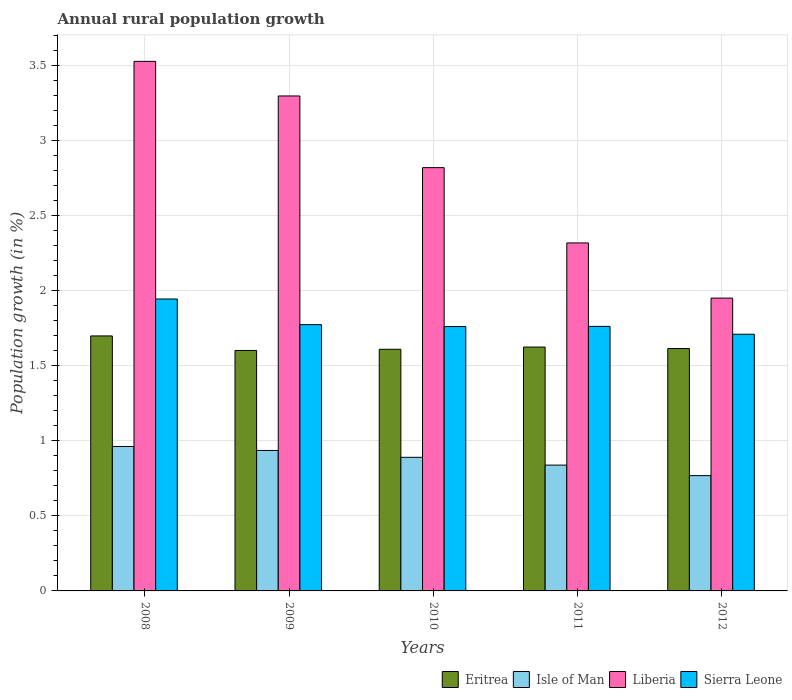How many different coloured bars are there?
Keep it short and to the point. 4. How many groups of bars are there?
Offer a very short reply. 5. What is the percentage of rural population growth in Isle of Man in 2009?
Give a very brief answer. 0.94. Across all years, what is the maximum percentage of rural population growth in Liberia?
Your answer should be compact. 3.53. Across all years, what is the minimum percentage of rural population growth in Eritrea?
Make the answer very short. 1.6. In which year was the percentage of rural population growth in Liberia minimum?
Offer a terse response. 2012. What is the total percentage of rural population growth in Liberia in the graph?
Keep it short and to the point. 13.93. What is the difference between the percentage of rural population growth in Sierra Leone in 2008 and that in 2012?
Ensure brevity in your answer.  0.24. What is the difference between the percentage of rural population growth in Sierra Leone in 2011 and the percentage of rural population growth in Eritrea in 2009?
Give a very brief answer. 0.16. What is the average percentage of rural population growth in Liberia per year?
Your response must be concise. 2.79. In the year 2012, what is the difference between the percentage of rural population growth in Liberia and percentage of rural population growth in Eritrea?
Your response must be concise. 0.34. In how many years, is the percentage of rural population growth in Liberia greater than 0.7 %?
Your response must be concise. 5. What is the ratio of the percentage of rural population growth in Liberia in 2010 to that in 2012?
Ensure brevity in your answer.  1.45. Is the percentage of rural population growth in Isle of Man in 2010 less than that in 2012?
Provide a short and direct response. No. Is the difference between the percentage of rural population growth in Liberia in 2009 and 2012 greater than the difference between the percentage of rural population growth in Eritrea in 2009 and 2012?
Make the answer very short. Yes. What is the difference between the highest and the second highest percentage of rural population growth in Sierra Leone?
Offer a terse response. 0.17. What is the difference between the highest and the lowest percentage of rural population growth in Liberia?
Provide a short and direct response. 1.58. What does the 3rd bar from the left in 2010 represents?
Offer a very short reply. Liberia. What does the 3rd bar from the right in 2012 represents?
Provide a short and direct response. Isle of Man. Is it the case that in every year, the sum of the percentage of rural population growth in Sierra Leone and percentage of rural population growth in Liberia is greater than the percentage of rural population growth in Isle of Man?
Offer a terse response. Yes. What is the difference between two consecutive major ticks on the Y-axis?
Your answer should be compact. 0.5. Are the values on the major ticks of Y-axis written in scientific E-notation?
Keep it short and to the point. No. Does the graph contain grids?
Your answer should be compact. Yes. Where does the legend appear in the graph?
Keep it short and to the point. Bottom right. How many legend labels are there?
Make the answer very short. 4. How are the legend labels stacked?
Provide a short and direct response. Horizontal. What is the title of the graph?
Ensure brevity in your answer.  Annual rural population growth. Does "Cayman Islands" appear as one of the legend labels in the graph?
Make the answer very short. No. What is the label or title of the X-axis?
Provide a succinct answer. Years. What is the label or title of the Y-axis?
Make the answer very short. Population growth (in %). What is the Population growth (in %) of Eritrea in 2008?
Ensure brevity in your answer.  1.7. What is the Population growth (in %) in Isle of Man in 2008?
Provide a succinct answer. 0.96. What is the Population growth (in %) in Liberia in 2008?
Offer a terse response. 3.53. What is the Population growth (in %) in Sierra Leone in 2008?
Ensure brevity in your answer.  1.95. What is the Population growth (in %) of Eritrea in 2009?
Keep it short and to the point. 1.6. What is the Population growth (in %) of Isle of Man in 2009?
Give a very brief answer. 0.94. What is the Population growth (in %) of Liberia in 2009?
Your answer should be very brief. 3.3. What is the Population growth (in %) of Sierra Leone in 2009?
Make the answer very short. 1.78. What is the Population growth (in %) of Eritrea in 2010?
Keep it short and to the point. 1.61. What is the Population growth (in %) of Isle of Man in 2010?
Give a very brief answer. 0.89. What is the Population growth (in %) of Liberia in 2010?
Your response must be concise. 2.82. What is the Population growth (in %) of Sierra Leone in 2010?
Make the answer very short. 1.76. What is the Population growth (in %) in Eritrea in 2011?
Your answer should be very brief. 1.63. What is the Population growth (in %) of Isle of Man in 2011?
Ensure brevity in your answer.  0.84. What is the Population growth (in %) in Liberia in 2011?
Keep it short and to the point. 2.32. What is the Population growth (in %) in Sierra Leone in 2011?
Your answer should be very brief. 1.76. What is the Population growth (in %) of Eritrea in 2012?
Your answer should be compact. 1.62. What is the Population growth (in %) in Isle of Man in 2012?
Give a very brief answer. 0.77. What is the Population growth (in %) of Liberia in 2012?
Offer a terse response. 1.95. What is the Population growth (in %) of Sierra Leone in 2012?
Keep it short and to the point. 1.71. Across all years, what is the maximum Population growth (in %) in Eritrea?
Keep it short and to the point. 1.7. Across all years, what is the maximum Population growth (in %) in Isle of Man?
Keep it short and to the point. 0.96. Across all years, what is the maximum Population growth (in %) of Liberia?
Provide a short and direct response. 3.53. Across all years, what is the maximum Population growth (in %) in Sierra Leone?
Offer a very short reply. 1.95. Across all years, what is the minimum Population growth (in %) of Eritrea?
Your answer should be very brief. 1.6. Across all years, what is the minimum Population growth (in %) in Isle of Man?
Make the answer very short. 0.77. Across all years, what is the minimum Population growth (in %) of Liberia?
Your response must be concise. 1.95. Across all years, what is the minimum Population growth (in %) in Sierra Leone?
Make the answer very short. 1.71. What is the total Population growth (in %) of Eritrea in the graph?
Ensure brevity in your answer.  8.16. What is the total Population growth (in %) in Isle of Man in the graph?
Provide a short and direct response. 4.4. What is the total Population growth (in %) in Liberia in the graph?
Offer a terse response. 13.93. What is the total Population growth (in %) in Sierra Leone in the graph?
Ensure brevity in your answer.  8.96. What is the difference between the Population growth (in %) in Eritrea in 2008 and that in 2009?
Your answer should be compact. 0.1. What is the difference between the Population growth (in %) of Isle of Man in 2008 and that in 2009?
Ensure brevity in your answer.  0.03. What is the difference between the Population growth (in %) in Liberia in 2008 and that in 2009?
Offer a terse response. 0.23. What is the difference between the Population growth (in %) of Sierra Leone in 2008 and that in 2009?
Ensure brevity in your answer.  0.17. What is the difference between the Population growth (in %) of Eritrea in 2008 and that in 2010?
Your answer should be very brief. 0.09. What is the difference between the Population growth (in %) of Isle of Man in 2008 and that in 2010?
Provide a short and direct response. 0.07. What is the difference between the Population growth (in %) in Liberia in 2008 and that in 2010?
Provide a short and direct response. 0.71. What is the difference between the Population growth (in %) of Sierra Leone in 2008 and that in 2010?
Offer a very short reply. 0.18. What is the difference between the Population growth (in %) of Eritrea in 2008 and that in 2011?
Ensure brevity in your answer.  0.07. What is the difference between the Population growth (in %) of Isle of Man in 2008 and that in 2011?
Make the answer very short. 0.12. What is the difference between the Population growth (in %) of Liberia in 2008 and that in 2011?
Keep it short and to the point. 1.21. What is the difference between the Population growth (in %) in Sierra Leone in 2008 and that in 2011?
Your response must be concise. 0.18. What is the difference between the Population growth (in %) of Eritrea in 2008 and that in 2012?
Your response must be concise. 0.08. What is the difference between the Population growth (in %) in Isle of Man in 2008 and that in 2012?
Your answer should be very brief. 0.19. What is the difference between the Population growth (in %) of Liberia in 2008 and that in 2012?
Provide a short and direct response. 1.58. What is the difference between the Population growth (in %) in Sierra Leone in 2008 and that in 2012?
Offer a very short reply. 0.24. What is the difference between the Population growth (in %) of Eritrea in 2009 and that in 2010?
Offer a very short reply. -0.01. What is the difference between the Population growth (in %) of Isle of Man in 2009 and that in 2010?
Provide a short and direct response. 0.05. What is the difference between the Population growth (in %) in Liberia in 2009 and that in 2010?
Your answer should be compact. 0.48. What is the difference between the Population growth (in %) of Sierra Leone in 2009 and that in 2010?
Provide a succinct answer. 0.01. What is the difference between the Population growth (in %) of Eritrea in 2009 and that in 2011?
Your answer should be compact. -0.02. What is the difference between the Population growth (in %) of Isle of Man in 2009 and that in 2011?
Your answer should be very brief. 0.1. What is the difference between the Population growth (in %) in Liberia in 2009 and that in 2011?
Provide a short and direct response. 0.98. What is the difference between the Population growth (in %) in Sierra Leone in 2009 and that in 2011?
Give a very brief answer. 0.01. What is the difference between the Population growth (in %) in Eritrea in 2009 and that in 2012?
Your answer should be compact. -0.01. What is the difference between the Population growth (in %) in Isle of Man in 2009 and that in 2012?
Keep it short and to the point. 0.17. What is the difference between the Population growth (in %) of Liberia in 2009 and that in 2012?
Your answer should be compact. 1.35. What is the difference between the Population growth (in %) in Sierra Leone in 2009 and that in 2012?
Provide a succinct answer. 0.06. What is the difference between the Population growth (in %) in Eritrea in 2010 and that in 2011?
Keep it short and to the point. -0.01. What is the difference between the Population growth (in %) in Isle of Man in 2010 and that in 2011?
Your answer should be compact. 0.05. What is the difference between the Population growth (in %) in Liberia in 2010 and that in 2011?
Your response must be concise. 0.5. What is the difference between the Population growth (in %) of Sierra Leone in 2010 and that in 2011?
Provide a short and direct response. -0. What is the difference between the Population growth (in %) in Eritrea in 2010 and that in 2012?
Give a very brief answer. -0.01. What is the difference between the Population growth (in %) in Isle of Man in 2010 and that in 2012?
Offer a very short reply. 0.12. What is the difference between the Population growth (in %) of Liberia in 2010 and that in 2012?
Your answer should be compact. 0.87. What is the difference between the Population growth (in %) in Sierra Leone in 2010 and that in 2012?
Make the answer very short. 0.05. What is the difference between the Population growth (in %) of Eritrea in 2011 and that in 2012?
Keep it short and to the point. 0.01. What is the difference between the Population growth (in %) of Isle of Man in 2011 and that in 2012?
Provide a succinct answer. 0.07. What is the difference between the Population growth (in %) in Liberia in 2011 and that in 2012?
Your response must be concise. 0.37. What is the difference between the Population growth (in %) of Sierra Leone in 2011 and that in 2012?
Provide a succinct answer. 0.05. What is the difference between the Population growth (in %) in Eritrea in 2008 and the Population growth (in %) in Isle of Man in 2009?
Give a very brief answer. 0.76. What is the difference between the Population growth (in %) of Eritrea in 2008 and the Population growth (in %) of Liberia in 2009?
Keep it short and to the point. -1.6. What is the difference between the Population growth (in %) of Eritrea in 2008 and the Population growth (in %) of Sierra Leone in 2009?
Ensure brevity in your answer.  -0.08. What is the difference between the Population growth (in %) of Isle of Man in 2008 and the Population growth (in %) of Liberia in 2009?
Ensure brevity in your answer.  -2.34. What is the difference between the Population growth (in %) of Isle of Man in 2008 and the Population growth (in %) of Sierra Leone in 2009?
Offer a terse response. -0.81. What is the difference between the Population growth (in %) in Liberia in 2008 and the Population growth (in %) in Sierra Leone in 2009?
Your answer should be compact. 1.76. What is the difference between the Population growth (in %) of Eritrea in 2008 and the Population growth (in %) of Isle of Man in 2010?
Make the answer very short. 0.81. What is the difference between the Population growth (in %) in Eritrea in 2008 and the Population growth (in %) in Liberia in 2010?
Give a very brief answer. -1.12. What is the difference between the Population growth (in %) in Eritrea in 2008 and the Population growth (in %) in Sierra Leone in 2010?
Your response must be concise. -0.06. What is the difference between the Population growth (in %) in Isle of Man in 2008 and the Population growth (in %) in Liberia in 2010?
Provide a succinct answer. -1.86. What is the difference between the Population growth (in %) of Isle of Man in 2008 and the Population growth (in %) of Sierra Leone in 2010?
Offer a very short reply. -0.8. What is the difference between the Population growth (in %) in Liberia in 2008 and the Population growth (in %) in Sierra Leone in 2010?
Make the answer very short. 1.77. What is the difference between the Population growth (in %) of Eritrea in 2008 and the Population growth (in %) of Isle of Man in 2011?
Offer a very short reply. 0.86. What is the difference between the Population growth (in %) of Eritrea in 2008 and the Population growth (in %) of Liberia in 2011?
Provide a short and direct response. -0.62. What is the difference between the Population growth (in %) of Eritrea in 2008 and the Population growth (in %) of Sierra Leone in 2011?
Your answer should be very brief. -0.06. What is the difference between the Population growth (in %) of Isle of Man in 2008 and the Population growth (in %) of Liberia in 2011?
Make the answer very short. -1.36. What is the difference between the Population growth (in %) in Isle of Man in 2008 and the Population growth (in %) in Sierra Leone in 2011?
Make the answer very short. -0.8. What is the difference between the Population growth (in %) in Liberia in 2008 and the Population growth (in %) in Sierra Leone in 2011?
Ensure brevity in your answer.  1.77. What is the difference between the Population growth (in %) in Eritrea in 2008 and the Population growth (in %) in Isle of Man in 2012?
Provide a succinct answer. 0.93. What is the difference between the Population growth (in %) of Eritrea in 2008 and the Population growth (in %) of Liberia in 2012?
Keep it short and to the point. -0.25. What is the difference between the Population growth (in %) of Eritrea in 2008 and the Population growth (in %) of Sierra Leone in 2012?
Your response must be concise. -0.01. What is the difference between the Population growth (in %) of Isle of Man in 2008 and the Population growth (in %) of Liberia in 2012?
Give a very brief answer. -0.99. What is the difference between the Population growth (in %) in Isle of Man in 2008 and the Population growth (in %) in Sierra Leone in 2012?
Your answer should be compact. -0.75. What is the difference between the Population growth (in %) in Liberia in 2008 and the Population growth (in %) in Sierra Leone in 2012?
Make the answer very short. 1.82. What is the difference between the Population growth (in %) of Eritrea in 2009 and the Population growth (in %) of Isle of Man in 2010?
Keep it short and to the point. 0.71. What is the difference between the Population growth (in %) of Eritrea in 2009 and the Population growth (in %) of Liberia in 2010?
Offer a terse response. -1.22. What is the difference between the Population growth (in %) in Eritrea in 2009 and the Population growth (in %) in Sierra Leone in 2010?
Provide a succinct answer. -0.16. What is the difference between the Population growth (in %) in Isle of Man in 2009 and the Population growth (in %) in Liberia in 2010?
Keep it short and to the point. -1.89. What is the difference between the Population growth (in %) of Isle of Man in 2009 and the Population growth (in %) of Sierra Leone in 2010?
Offer a very short reply. -0.83. What is the difference between the Population growth (in %) of Liberia in 2009 and the Population growth (in %) of Sierra Leone in 2010?
Your response must be concise. 1.54. What is the difference between the Population growth (in %) of Eritrea in 2009 and the Population growth (in %) of Isle of Man in 2011?
Provide a short and direct response. 0.76. What is the difference between the Population growth (in %) in Eritrea in 2009 and the Population growth (in %) in Liberia in 2011?
Your response must be concise. -0.72. What is the difference between the Population growth (in %) in Eritrea in 2009 and the Population growth (in %) in Sierra Leone in 2011?
Provide a succinct answer. -0.16. What is the difference between the Population growth (in %) in Isle of Man in 2009 and the Population growth (in %) in Liberia in 2011?
Ensure brevity in your answer.  -1.38. What is the difference between the Population growth (in %) in Isle of Man in 2009 and the Population growth (in %) in Sierra Leone in 2011?
Offer a terse response. -0.83. What is the difference between the Population growth (in %) in Liberia in 2009 and the Population growth (in %) in Sierra Leone in 2011?
Ensure brevity in your answer.  1.54. What is the difference between the Population growth (in %) in Eritrea in 2009 and the Population growth (in %) in Isle of Man in 2012?
Ensure brevity in your answer.  0.83. What is the difference between the Population growth (in %) of Eritrea in 2009 and the Population growth (in %) of Liberia in 2012?
Your answer should be compact. -0.35. What is the difference between the Population growth (in %) in Eritrea in 2009 and the Population growth (in %) in Sierra Leone in 2012?
Provide a succinct answer. -0.11. What is the difference between the Population growth (in %) in Isle of Man in 2009 and the Population growth (in %) in Liberia in 2012?
Give a very brief answer. -1.02. What is the difference between the Population growth (in %) of Isle of Man in 2009 and the Population growth (in %) of Sierra Leone in 2012?
Provide a succinct answer. -0.77. What is the difference between the Population growth (in %) in Liberia in 2009 and the Population growth (in %) in Sierra Leone in 2012?
Your answer should be compact. 1.59. What is the difference between the Population growth (in %) in Eritrea in 2010 and the Population growth (in %) in Isle of Man in 2011?
Your answer should be very brief. 0.77. What is the difference between the Population growth (in %) of Eritrea in 2010 and the Population growth (in %) of Liberia in 2011?
Offer a terse response. -0.71. What is the difference between the Population growth (in %) in Eritrea in 2010 and the Population growth (in %) in Sierra Leone in 2011?
Give a very brief answer. -0.15. What is the difference between the Population growth (in %) in Isle of Man in 2010 and the Population growth (in %) in Liberia in 2011?
Keep it short and to the point. -1.43. What is the difference between the Population growth (in %) of Isle of Man in 2010 and the Population growth (in %) of Sierra Leone in 2011?
Offer a very short reply. -0.87. What is the difference between the Population growth (in %) in Liberia in 2010 and the Population growth (in %) in Sierra Leone in 2011?
Your answer should be very brief. 1.06. What is the difference between the Population growth (in %) of Eritrea in 2010 and the Population growth (in %) of Isle of Man in 2012?
Your response must be concise. 0.84. What is the difference between the Population growth (in %) in Eritrea in 2010 and the Population growth (in %) in Liberia in 2012?
Give a very brief answer. -0.34. What is the difference between the Population growth (in %) of Eritrea in 2010 and the Population growth (in %) of Sierra Leone in 2012?
Provide a short and direct response. -0.1. What is the difference between the Population growth (in %) of Isle of Man in 2010 and the Population growth (in %) of Liberia in 2012?
Provide a succinct answer. -1.06. What is the difference between the Population growth (in %) in Isle of Man in 2010 and the Population growth (in %) in Sierra Leone in 2012?
Give a very brief answer. -0.82. What is the difference between the Population growth (in %) in Liberia in 2010 and the Population growth (in %) in Sierra Leone in 2012?
Offer a terse response. 1.11. What is the difference between the Population growth (in %) of Eritrea in 2011 and the Population growth (in %) of Isle of Man in 2012?
Your answer should be very brief. 0.86. What is the difference between the Population growth (in %) in Eritrea in 2011 and the Population growth (in %) in Liberia in 2012?
Make the answer very short. -0.33. What is the difference between the Population growth (in %) in Eritrea in 2011 and the Population growth (in %) in Sierra Leone in 2012?
Your answer should be very brief. -0.09. What is the difference between the Population growth (in %) of Isle of Man in 2011 and the Population growth (in %) of Liberia in 2012?
Offer a very short reply. -1.11. What is the difference between the Population growth (in %) of Isle of Man in 2011 and the Population growth (in %) of Sierra Leone in 2012?
Ensure brevity in your answer.  -0.87. What is the difference between the Population growth (in %) of Liberia in 2011 and the Population growth (in %) of Sierra Leone in 2012?
Offer a very short reply. 0.61. What is the average Population growth (in %) of Eritrea per year?
Your answer should be very brief. 1.63. What is the average Population growth (in %) of Isle of Man per year?
Give a very brief answer. 0.88. What is the average Population growth (in %) in Liberia per year?
Offer a terse response. 2.79. What is the average Population growth (in %) in Sierra Leone per year?
Provide a succinct answer. 1.79. In the year 2008, what is the difference between the Population growth (in %) in Eritrea and Population growth (in %) in Isle of Man?
Ensure brevity in your answer.  0.74. In the year 2008, what is the difference between the Population growth (in %) in Eritrea and Population growth (in %) in Liberia?
Make the answer very short. -1.83. In the year 2008, what is the difference between the Population growth (in %) in Eritrea and Population growth (in %) in Sierra Leone?
Your answer should be compact. -0.25. In the year 2008, what is the difference between the Population growth (in %) of Isle of Man and Population growth (in %) of Liberia?
Your answer should be compact. -2.57. In the year 2008, what is the difference between the Population growth (in %) of Isle of Man and Population growth (in %) of Sierra Leone?
Ensure brevity in your answer.  -0.98. In the year 2008, what is the difference between the Population growth (in %) in Liberia and Population growth (in %) in Sierra Leone?
Keep it short and to the point. 1.58. In the year 2009, what is the difference between the Population growth (in %) of Eritrea and Population growth (in %) of Liberia?
Your response must be concise. -1.7. In the year 2009, what is the difference between the Population growth (in %) in Eritrea and Population growth (in %) in Sierra Leone?
Make the answer very short. -0.17. In the year 2009, what is the difference between the Population growth (in %) of Isle of Man and Population growth (in %) of Liberia?
Offer a terse response. -2.36. In the year 2009, what is the difference between the Population growth (in %) of Isle of Man and Population growth (in %) of Sierra Leone?
Offer a very short reply. -0.84. In the year 2009, what is the difference between the Population growth (in %) of Liberia and Population growth (in %) of Sierra Leone?
Your answer should be very brief. 1.52. In the year 2010, what is the difference between the Population growth (in %) in Eritrea and Population growth (in %) in Isle of Man?
Provide a succinct answer. 0.72. In the year 2010, what is the difference between the Population growth (in %) in Eritrea and Population growth (in %) in Liberia?
Give a very brief answer. -1.21. In the year 2010, what is the difference between the Population growth (in %) in Eritrea and Population growth (in %) in Sierra Leone?
Ensure brevity in your answer.  -0.15. In the year 2010, what is the difference between the Population growth (in %) of Isle of Man and Population growth (in %) of Liberia?
Give a very brief answer. -1.93. In the year 2010, what is the difference between the Population growth (in %) in Isle of Man and Population growth (in %) in Sierra Leone?
Give a very brief answer. -0.87. In the year 2010, what is the difference between the Population growth (in %) in Liberia and Population growth (in %) in Sierra Leone?
Your answer should be compact. 1.06. In the year 2011, what is the difference between the Population growth (in %) of Eritrea and Population growth (in %) of Isle of Man?
Your answer should be compact. 0.79. In the year 2011, what is the difference between the Population growth (in %) of Eritrea and Population growth (in %) of Liberia?
Keep it short and to the point. -0.69. In the year 2011, what is the difference between the Population growth (in %) in Eritrea and Population growth (in %) in Sierra Leone?
Give a very brief answer. -0.14. In the year 2011, what is the difference between the Population growth (in %) of Isle of Man and Population growth (in %) of Liberia?
Offer a terse response. -1.48. In the year 2011, what is the difference between the Population growth (in %) of Isle of Man and Population growth (in %) of Sierra Leone?
Make the answer very short. -0.92. In the year 2011, what is the difference between the Population growth (in %) in Liberia and Population growth (in %) in Sierra Leone?
Ensure brevity in your answer.  0.56. In the year 2012, what is the difference between the Population growth (in %) of Eritrea and Population growth (in %) of Isle of Man?
Ensure brevity in your answer.  0.85. In the year 2012, what is the difference between the Population growth (in %) in Eritrea and Population growth (in %) in Liberia?
Your answer should be very brief. -0.34. In the year 2012, what is the difference between the Population growth (in %) in Eritrea and Population growth (in %) in Sierra Leone?
Provide a succinct answer. -0.1. In the year 2012, what is the difference between the Population growth (in %) of Isle of Man and Population growth (in %) of Liberia?
Give a very brief answer. -1.18. In the year 2012, what is the difference between the Population growth (in %) of Isle of Man and Population growth (in %) of Sierra Leone?
Your response must be concise. -0.94. In the year 2012, what is the difference between the Population growth (in %) in Liberia and Population growth (in %) in Sierra Leone?
Offer a terse response. 0.24. What is the ratio of the Population growth (in %) of Eritrea in 2008 to that in 2009?
Give a very brief answer. 1.06. What is the ratio of the Population growth (in %) in Isle of Man in 2008 to that in 2009?
Keep it short and to the point. 1.03. What is the ratio of the Population growth (in %) in Liberia in 2008 to that in 2009?
Provide a short and direct response. 1.07. What is the ratio of the Population growth (in %) in Sierra Leone in 2008 to that in 2009?
Your response must be concise. 1.1. What is the ratio of the Population growth (in %) in Eritrea in 2008 to that in 2010?
Give a very brief answer. 1.06. What is the ratio of the Population growth (in %) of Isle of Man in 2008 to that in 2010?
Offer a terse response. 1.08. What is the ratio of the Population growth (in %) of Liberia in 2008 to that in 2010?
Offer a very short reply. 1.25. What is the ratio of the Population growth (in %) of Sierra Leone in 2008 to that in 2010?
Offer a very short reply. 1.1. What is the ratio of the Population growth (in %) of Eritrea in 2008 to that in 2011?
Ensure brevity in your answer.  1.05. What is the ratio of the Population growth (in %) in Isle of Man in 2008 to that in 2011?
Offer a very short reply. 1.15. What is the ratio of the Population growth (in %) in Liberia in 2008 to that in 2011?
Keep it short and to the point. 1.52. What is the ratio of the Population growth (in %) of Sierra Leone in 2008 to that in 2011?
Give a very brief answer. 1.1. What is the ratio of the Population growth (in %) in Eritrea in 2008 to that in 2012?
Provide a succinct answer. 1.05. What is the ratio of the Population growth (in %) of Isle of Man in 2008 to that in 2012?
Provide a short and direct response. 1.25. What is the ratio of the Population growth (in %) of Liberia in 2008 to that in 2012?
Give a very brief answer. 1.81. What is the ratio of the Population growth (in %) in Sierra Leone in 2008 to that in 2012?
Your answer should be compact. 1.14. What is the ratio of the Population growth (in %) of Eritrea in 2009 to that in 2010?
Make the answer very short. 1. What is the ratio of the Population growth (in %) in Isle of Man in 2009 to that in 2010?
Provide a short and direct response. 1.05. What is the ratio of the Population growth (in %) in Liberia in 2009 to that in 2010?
Offer a very short reply. 1.17. What is the ratio of the Population growth (in %) in Sierra Leone in 2009 to that in 2010?
Provide a succinct answer. 1.01. What is the ratio of the Population growth (in %) in Eritrea in 2009 to that in 2011?
Your response must be concise. 0.99. What is the ratio of the Population growth (in %) of Isle of Man in 2009 to that in 2011?
Your response must be concise. 1.12. What is the ratio of the Population growth (in %) of Liberia in 2009 to that in 2011?
Provide a short and direct response. 1.42. What is the ratio of the Population growth (in %) of Sierra Leone in 2009 to that in 2011?
Offer a terse response. 1.01. What is the ratio of the Population growth (in %) in Isle of Man in 2009 to that in 2012?
Make the answer very short. 1.22. What is the ratio of the Population growth (in %) of Liberia in 2009 to that in 2012?
Keep it short and to the point. 1.69. What is the ratio of the Population growth (in %) in Sierra Leone in 2009 to that in 2012?
Your answer should be very brief. 1.04. What is the ratio of the Population growth (in %) of Eritrea in 2010 to that in 2011?
Your response must be concise. 0.99. What is the ratio of the Population growth (in %) in Isle of Man in 2010 to that in 2011?
Provide a short and direct response. 1.06. What is the ratio of the Population growth (in %) in Liberia in 2010 to that in 2011?
Keep it short and to the point. 1.22. What is the ratio of the Population growth (in %) in Isle of Man in 2010 to that in 2012?
Give a very brief answer. 1.16. What is the ratio of the Population growth (in %) in Liberia in 2010 to that in 2012?
Your response must be concise. 1.45. What is the ratio of the Population growth (in %) in Sierra Leone in 2010 to that in 2012?
Provide a short and direct response. 1.03. What is the ratio of the Population growth (in %) in Isle of Man in 2011 to that in 2012?
Keep it short and to the point. 1.09. What is the ratio of the Population growth (in %) in Liberia in 2011 to that in 2012?
Offer a very short reply. 1.19. What is the ratio of the Population growth (in %) of Sierra Leone in 2011 to that in 2012?
Provide a succinct answer. 1.03. What is the difference between the highest and the second highest Population growth (in %) of Eritrea?
Offer a terse response. 0.07. What is the difference between the highest and the second highest Population growth (in %) of Isle of Man?
Provide a short and direct response. 0.03. What is the difference between the highest and the second highest Population growth (in %) of Liberia?
Your answer should be very brief. 0.23. What is the difference between the highest and the second highest Population growth (in %) in Sierra Leone?
Provide a short and direct response. 0.17. What is the difference between the highest and the lowest Population growth (in %) of Eritrea?
Give a very brief answer. 0.1. What is the difference between the highest and the lowest Population growth (in %) in Isle of Man?
Provide a succinct answer. 0.19. What is the difference between the highest and the lowest Population growth (in %) of Liberia?
Your response must be concise. 1.58. What is the difference between the highest and the lowest Population growth (in %) of Sierra Leone?
Your answer should be very brief. 0.24. 